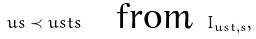Convert formula to latex. <formula><loc_0><loc_0><loc_500><loc_500>u s \prec u s t s \quad \text {from } I _ { u s t , s } ,</formula> 